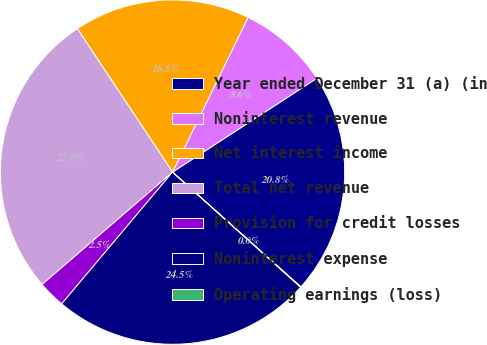<chart> <loc_0><loc_0><loc_500><loc_500><pie_chart><fcel>Year ended December 31 (a) (in<fcel>Noninterest revenue<fcel>Net interest income<fcel>Total net revenue<fcel>Provision for credit losses<fcel>Noninterest expense<fcel>Operating earnings (loss)<nl><fcel>20.79%<fcel>8.6%<fcel>16.55%<fcel>26.99%<fcel>2.55%<fcel>24.48%<fcel>0.04%<nl></chart> 